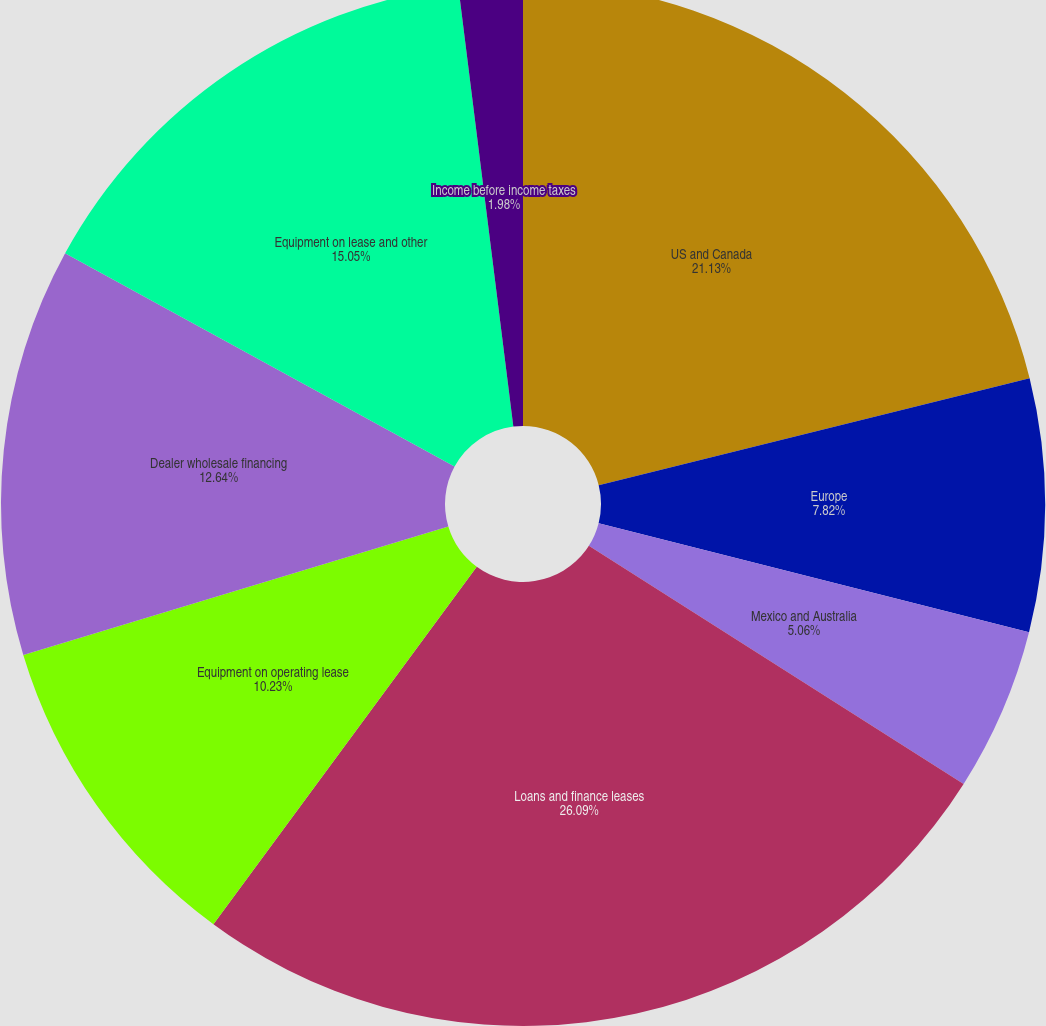Convert chart. <chart><loc_0><loc_0><loc_500><loc_500><pie_chart><fcel>US and Canada<fcel>Europe<fcel>Mexico and Australia<fcel>Loans and finance leases<fcel>Equipment on operating lease<fcel>Dealer wholesale financing<fcel>Equipment on lease and other<fcel>Income before income taxes<nl><fcel>21.13%<fcel>7.82%<fcel>5.06%<fcel>26.1%<fcel>10.23%<fcel>12.64%<fcel>15.05%<fcel>1.98%<nl></chart> 